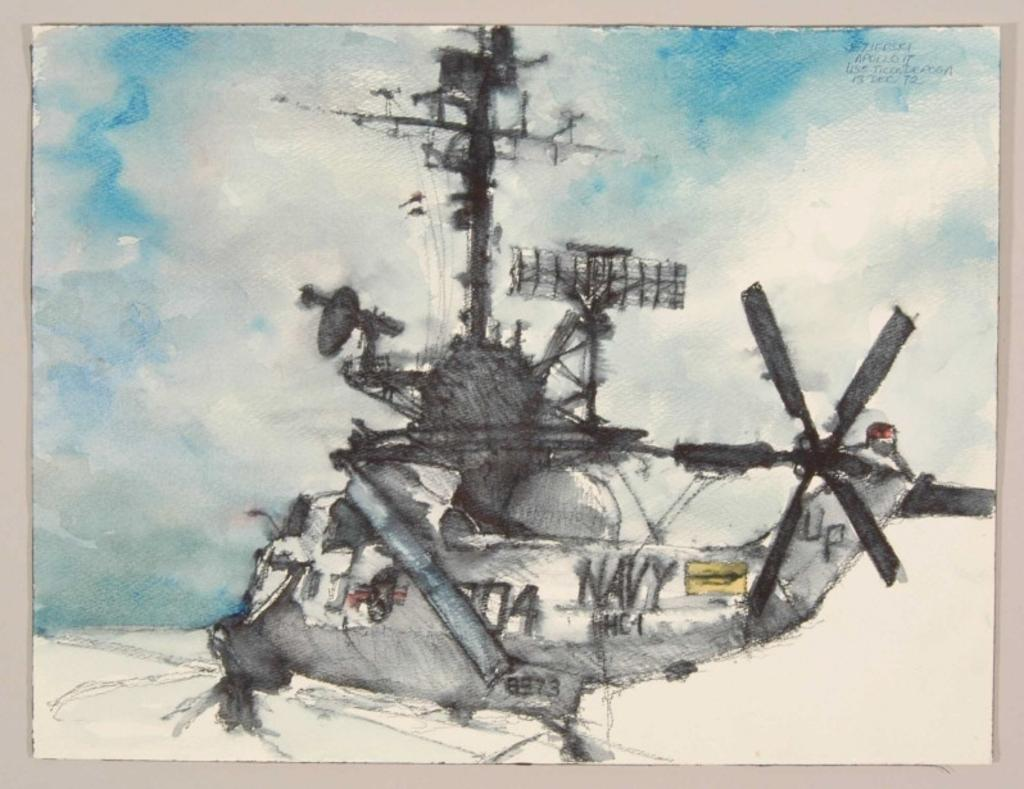<image>
Share a concise interpretation of the image provided. A water color painting of a Navy helicopter landing on a carrier. 